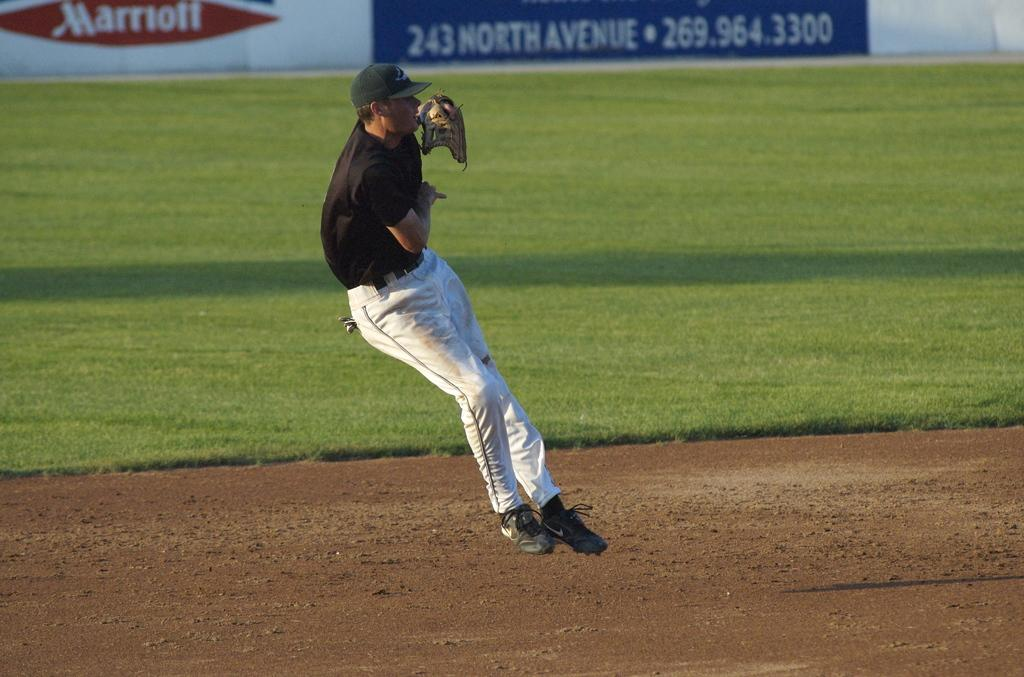<image>
Render a clear and concise summary of the photo. A baseball player jumps on the field in front of an advertising sign for Marriott and another sign with the address 243 North Avenue on it. 